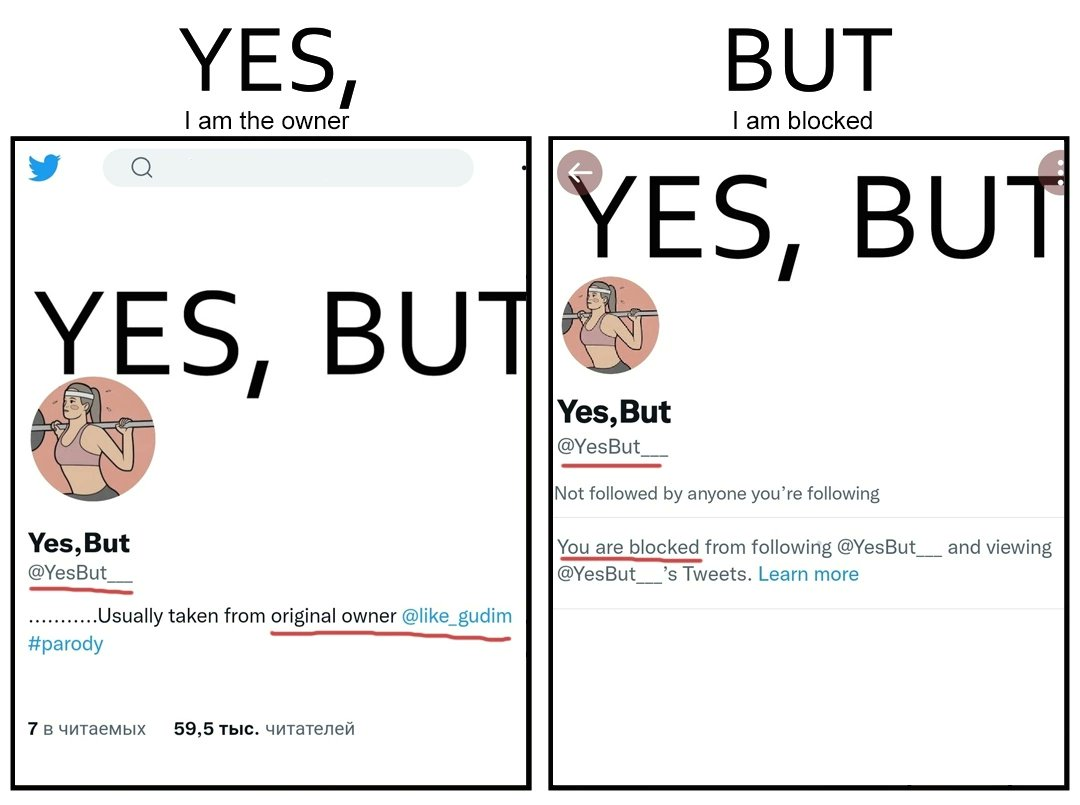Is there satirical content in this image? Yes, this image is satirical. 